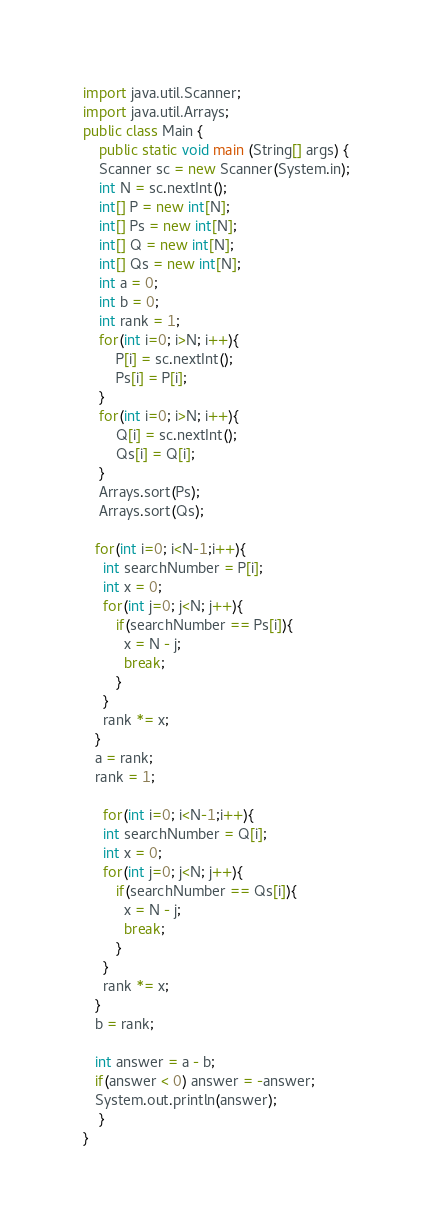Convert code to text. <code><loc_0><loc_0><loc_500><loc_500><_Java_>import java.util.Scanner;
import java.util.Arrays;
public class Main {
    public static void main (String[] args) {
    Scanner sc = new Scanner(System.in);
	int N = sc.nextInt();
    int[] P = new int[N];
    int[] Ps = new int[N];
    int[] Q = new int[N];
    int[] Qs = new int[N];
    int a = 0; 
    int b = 0;
    int rank = 1;
    for(int i=0; i>N; i++){
    	P[i] = sc.nextInt();
        Ps[i] = P[i];
    }
    for(int i=0; i>N; i++){
    	Q[i] = sc.nextInt();
        Qs[i] = Q[i];
    } 
    Arrays.sort(Ps);
    Arrays.sort(Qs);
      
   for(int i=0; i<N-1;i++){
     int searchNumber = P[i];
     int x = 0;
     for(int j=0; j<N; j++){
     	if(searchNumber == Ps[i]){
          x = N - j;
          break;
        }
     }
   	 rank *= x;
   }
   a = rank;
   rank = 1;
      
     for(int i=0; i<N-1;i++){
     int searchNumber = Q[i];
     int x = 0;
     for(int j=0; j<N; j++){
     	if(searchNumber == Qs[i]){
          x = N - j;
          break;
        }
     }
   	 rank *= x;
   }
   b = rank;
      
   int answer = a - b;
   if(answer < 0) answer = -answer;
   System.out.println(answer);   
    }
}
</code> 